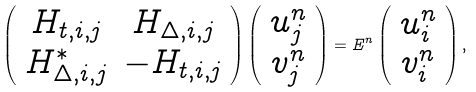<formula> <loc_0><loc_0><loc_500><loc_500>\left ( { \begin{array} { c c } H _ { t , i , j } & H _ { \Delta , i , j } \\ H ^ { * } _ { \Delta , i , j } & - H _ { t , i , j } \\ \end{array} } \right ) \left ( { \begin{array} { c } u ^ { n } _ { j } \\ v ^ { n } _ { j } \\ \end{array} } \right ) = E ^ { n } \left ( { \begin{array} { c } u ^ { n } _ { i } \\ v ^ { n } _ { i } \\ \end{array} } \right ) ,</formula> 